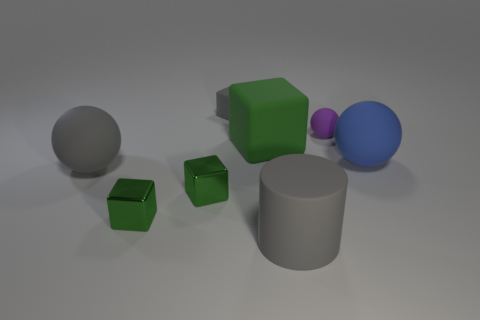Add 1 big blue rubber blocks. How many objects exist? 9 Subtract all gray blocks. How many blocks are left? 3 Subtract 1 cylinders. How many cylinders are left? 0 Subtract all cylinders. How many objects are left? 7 Subtract all brown spheres. How many green cylinders are left? 0 Subtract all gray cubes. How many cubes are left? 3 Subtract 0 red cylinders. How many objects are left? 8 Subtract all green cubes. Subtract all yellow balls. How many cubes are left? 1 Subtract all purple spheres. Subtract all big gray matte things. How many objects are left? 5 Add 4 small rubber cubes. How many small rubber cubes are left? 5 